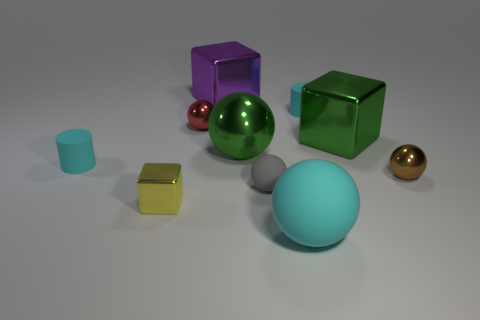What is the shape of the thing in front of the yellow shiny thing?
Give a very brief answer. Sphere. There is a cyan thing that is in front of the small metallic sphere on the right side of the small shiny sphere to the left of the big purple metal thing; how big is it?
Make the answer very short. Large. There is a small sphere that is on the left side of the large purple cube; how many cyan things are in front of it?
Ensure brevity in your answer.  2. There is a metal object that is both left of the gray sphere and on the right side of the large purple thing; how big is it?
Offer a very short reply. Large. How many shiny objects are small gray balls or yellow objects?
Give a very brief answer. 1. What is the material of the big green cube?
Give a very brief answer. Metal. There is a big cube that is behind the matte cylinder that is behind the cyan object on the left side of the tiny red shiny sphere; what is it made of?
Keep it short and to the point. Metal. There is a red metallic thing that is the same size as the yellow shiny thing; what is its shape?
Make the answer very short. Sphere. What number of objects are either purple blocks or metal things that are behind the red sphere?
Provide a short and direct response. 1. Are the cylinder that is left of the purple metallic cube and the small cylinder behind the small red thing made of the same material?
Keep it short and to the point. Yes. 